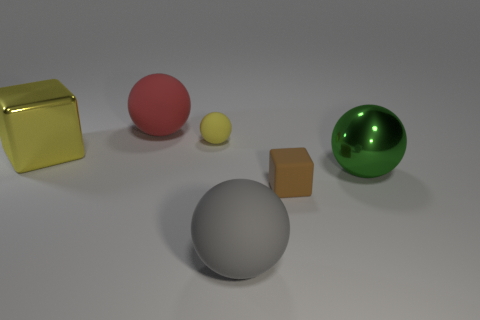Subtract all big metallic spheres. How many spheres are left? 3 Subtract 2 spheres. How many spheres are left? 2 Add 2 big gray objects. How many objects exist? 8 Subtract all red balls. How many balls are left? 3 Subtract all balls. How many objects are left? 2 Subtract 0 red cylinders. How many objects are left? 6 Subtract all gray spheres. Subtract all brown cylinders. How many spheres are left? 3 Subtract all yellow spheres. How many red blocks are left? 0 Subtract all yellow rubber objects. Subtract all tiny purple matte cylinders. How many objects are left? 5 Add 2 gray balls. How many gray balls are left? 3 